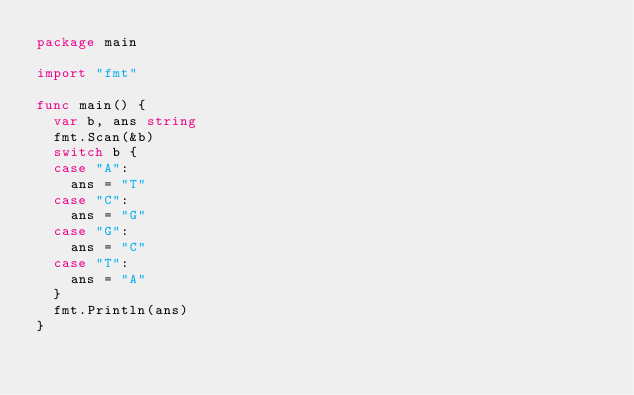<code> <loc_0><loc_0><loc_500><loc_500><_Go_>package main

import "fmt"

func main() {
	var b, ans string
	fmt.Scan(&b)
	switch b {
	case "A":
		ans = "T"
	case "C":
		ans = "G"
	case "G":
		ans = "C"
	case "T":
		ans = "A"
	}
	fmt.Println(ans)
}
</code> 